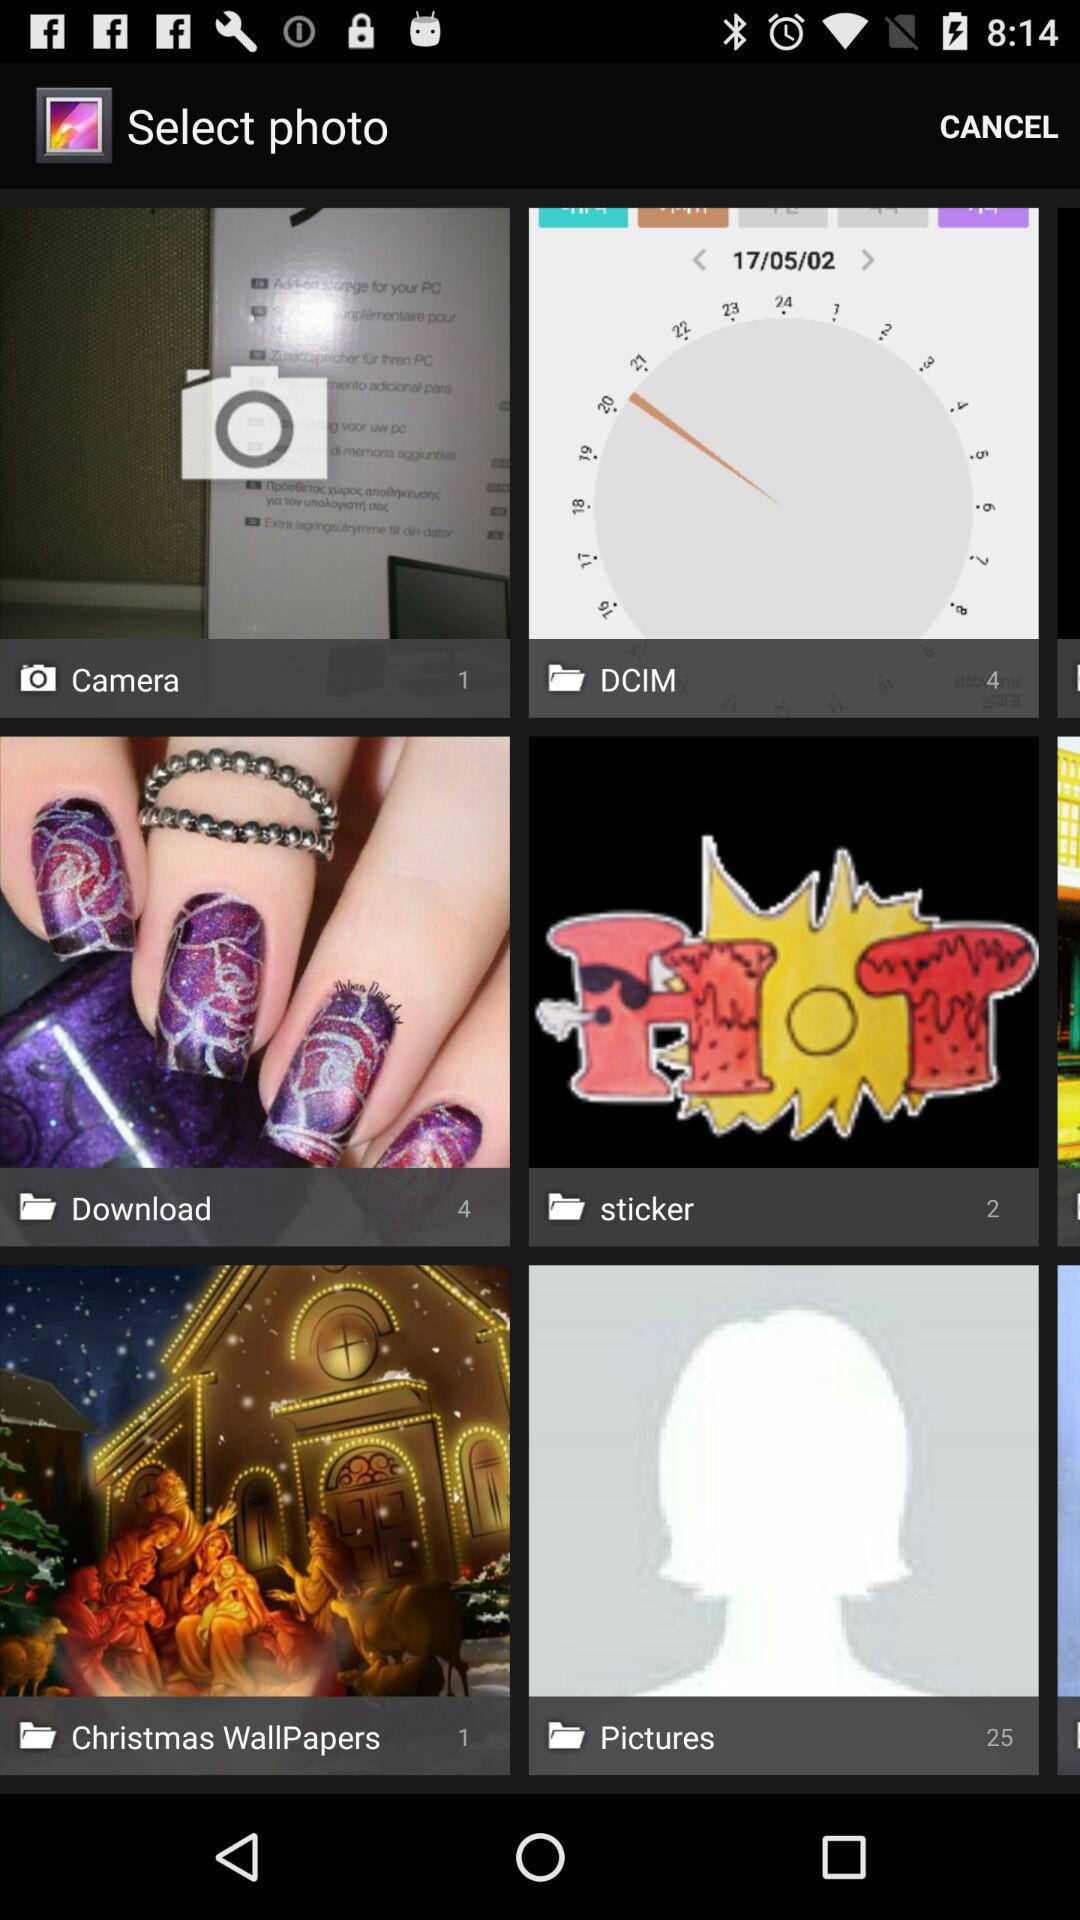How many pictures are available in "Camera"? The number of pictures that are available in "Camera" is 1. 